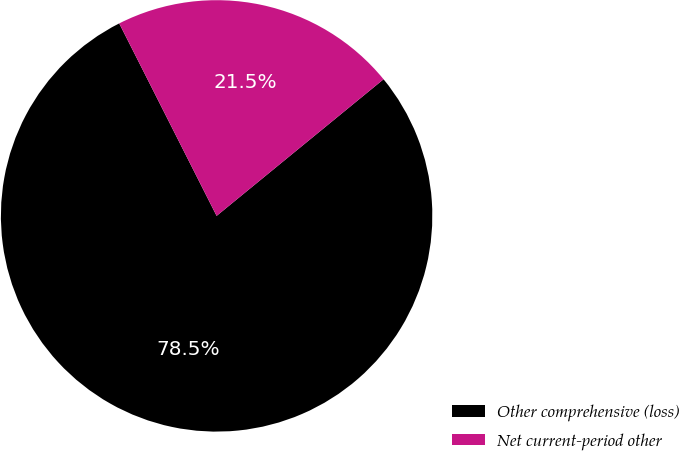Convert chart to OTSL. <chart><loc_0><loc_0><loc_500><loc_500><pie_chart><fcel>Other comprehensive (loss)<fcel>Net current-period other<nl><fcel>78.46%<fcel>21.54%<nl></chart> 